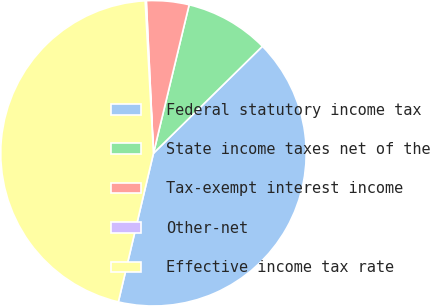Convert chart. <chart><loc_0><loc_0><loc_500><loc_500><pie_chart><fcel>Federal statutory income tax<fcel>State income taxes net of the<fcel>Tax-exempt interest income<fcel>Other-net<fcel>Effective income tax rate<nl><fcel>41.05%<fcel>8.89%<fcel>4.5%<fcel>0.12%<fcel>45.44%<nl></chart> 